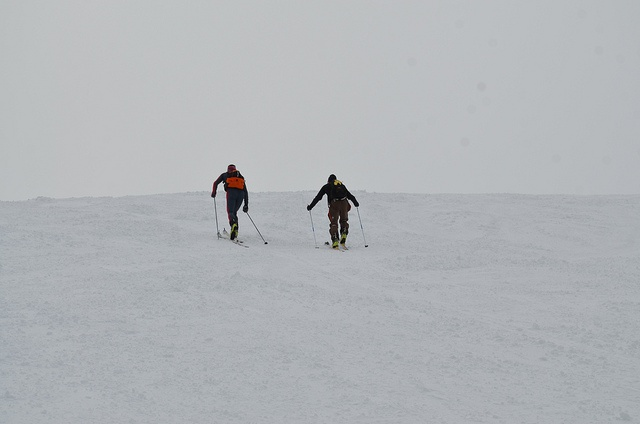Describe the objects in this image and their specific colors. I can see people in lightgray, black, gray, darkgray, and olive tones, people in lightgray, black, maroon, and gray tones, backpack in lightgray, black, gray, and olive tones, skis in lightgray, darkgray, and gray tones, and skis in lightgray and gray tones in this image. 